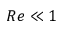Convert formula to latex. <formula><loc_0><loc_0><loc_500><loc_500>R e \ll 1</formula> 